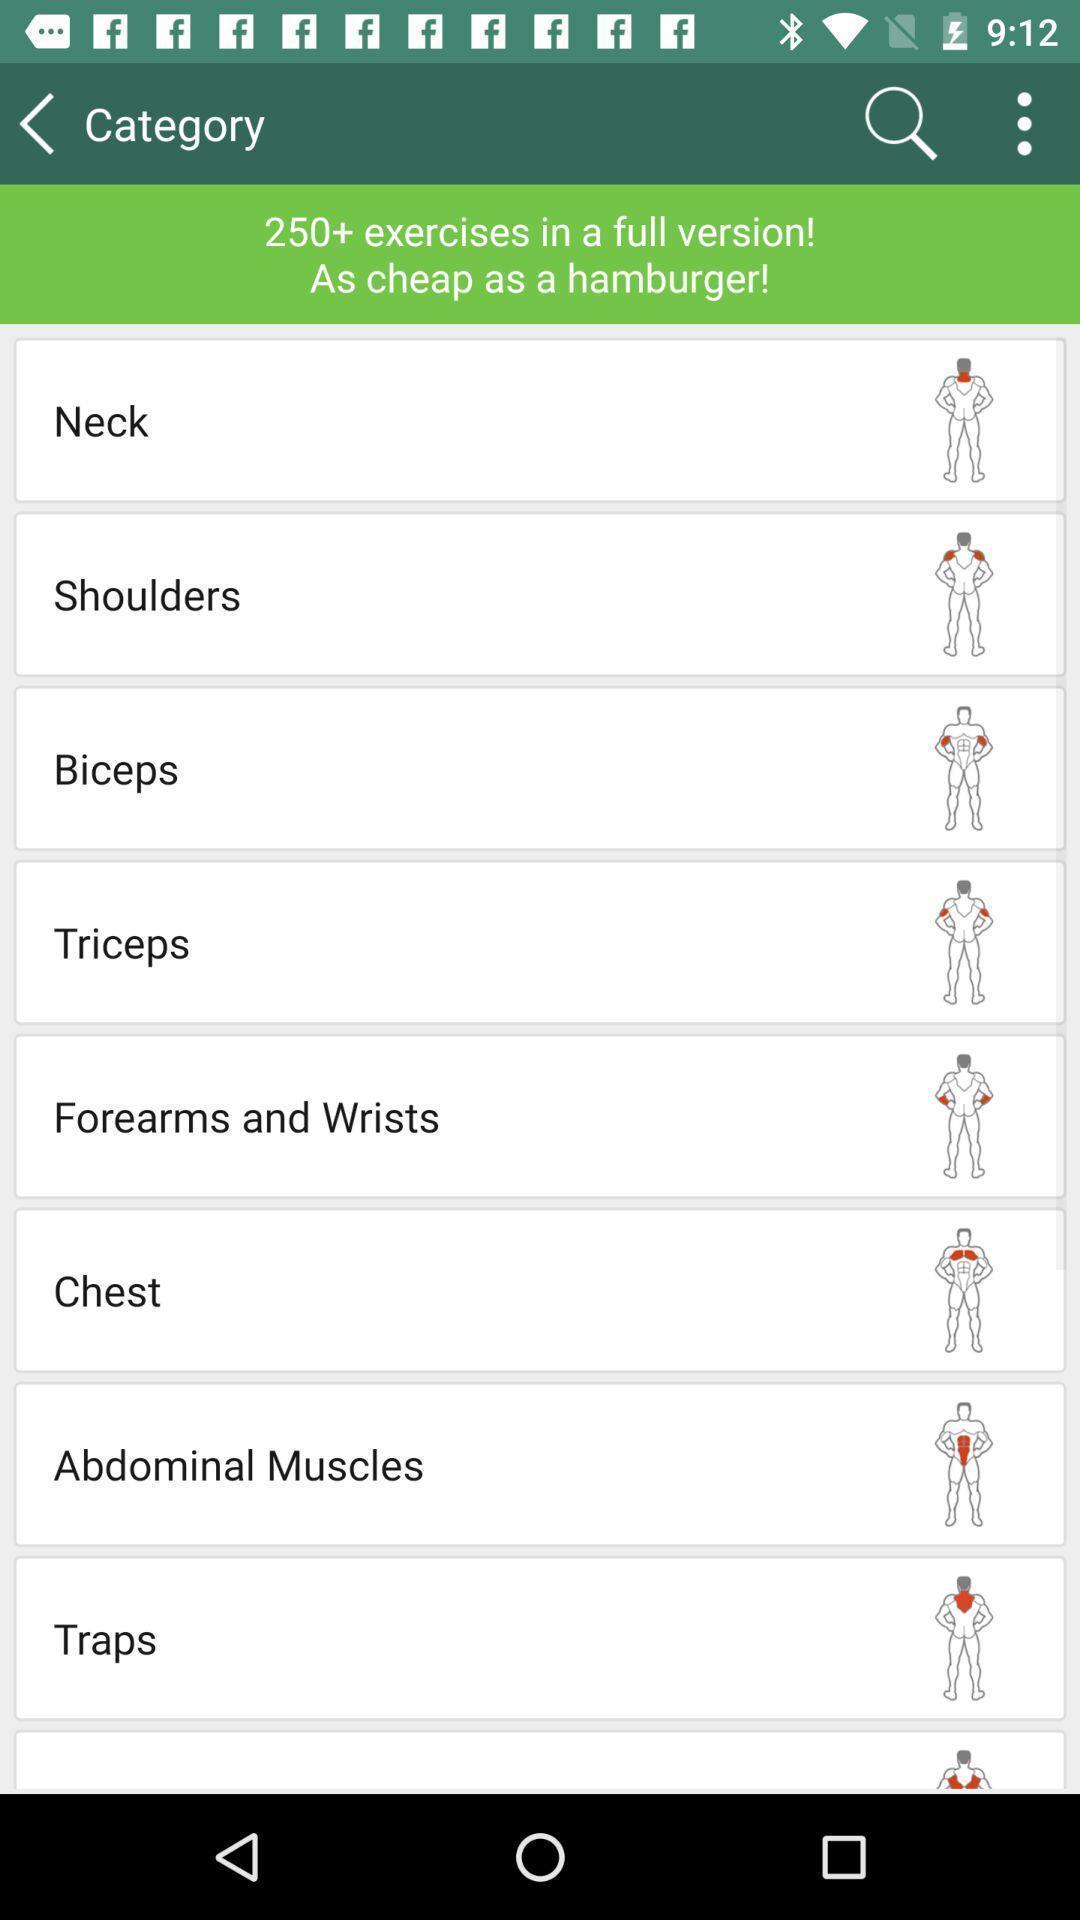Describe this image in words. Page displaying the list of categories. 